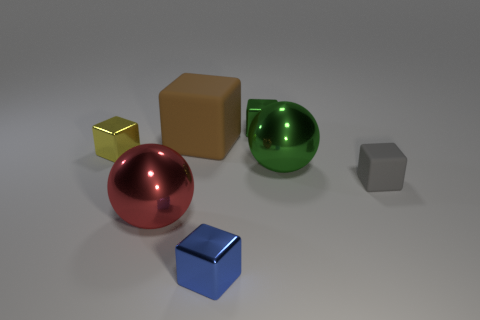Subtract all gray matte blocks. How many blocks are left? 4 Subtract all gray cubes. How many cubes are left? 4 Subtract all purple cubes. Subtract all gray spheres. How many cubes are left? 5 Add 1 large purple matte cylinders. How many objects exist? 8 Subtract all balls. How many objects are left? 5 Add 1 red metal spheres. How many red metal spheres exist? 2 Subtract 0 purple cylinders. How many objects are left? 7 Subtract all green balls. Subtract all yellow blocks. How many objects are left? 5 Add 3 big brown cubes. How many big brown cubes are left? 4 